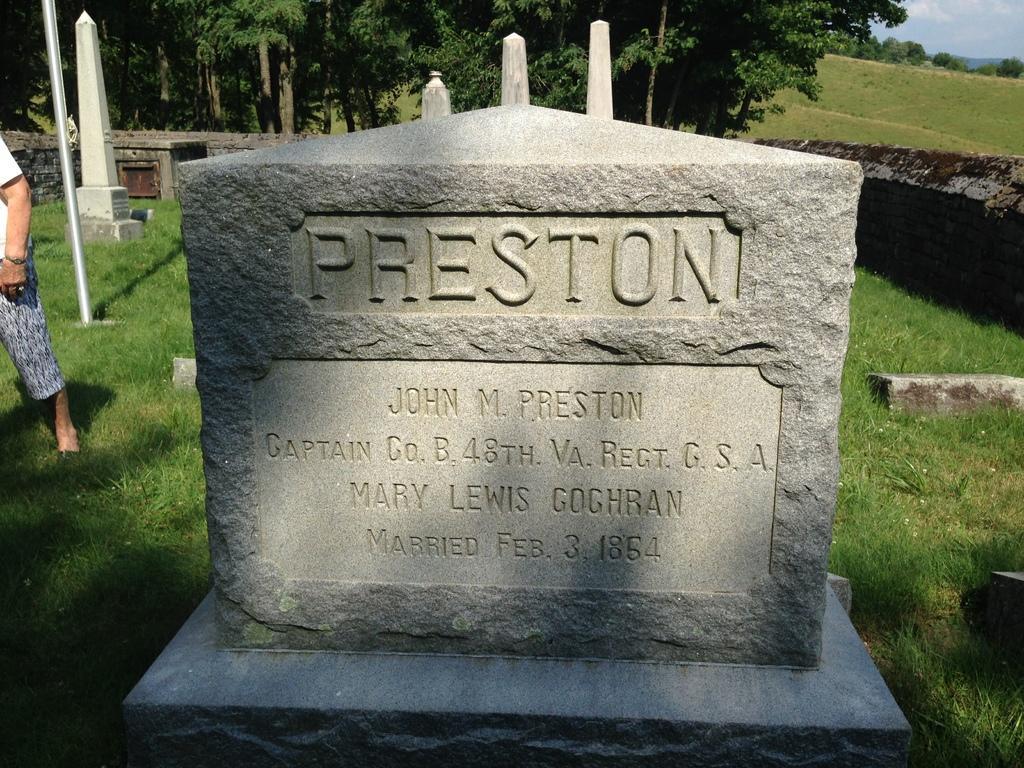Please provide a concise description of this image. In this image there is a cemetery having some text. Left side a person is standing on the grassland having a pole and cemeteries. Right side there is a wall. Background there are trees. Right top there is sky. 